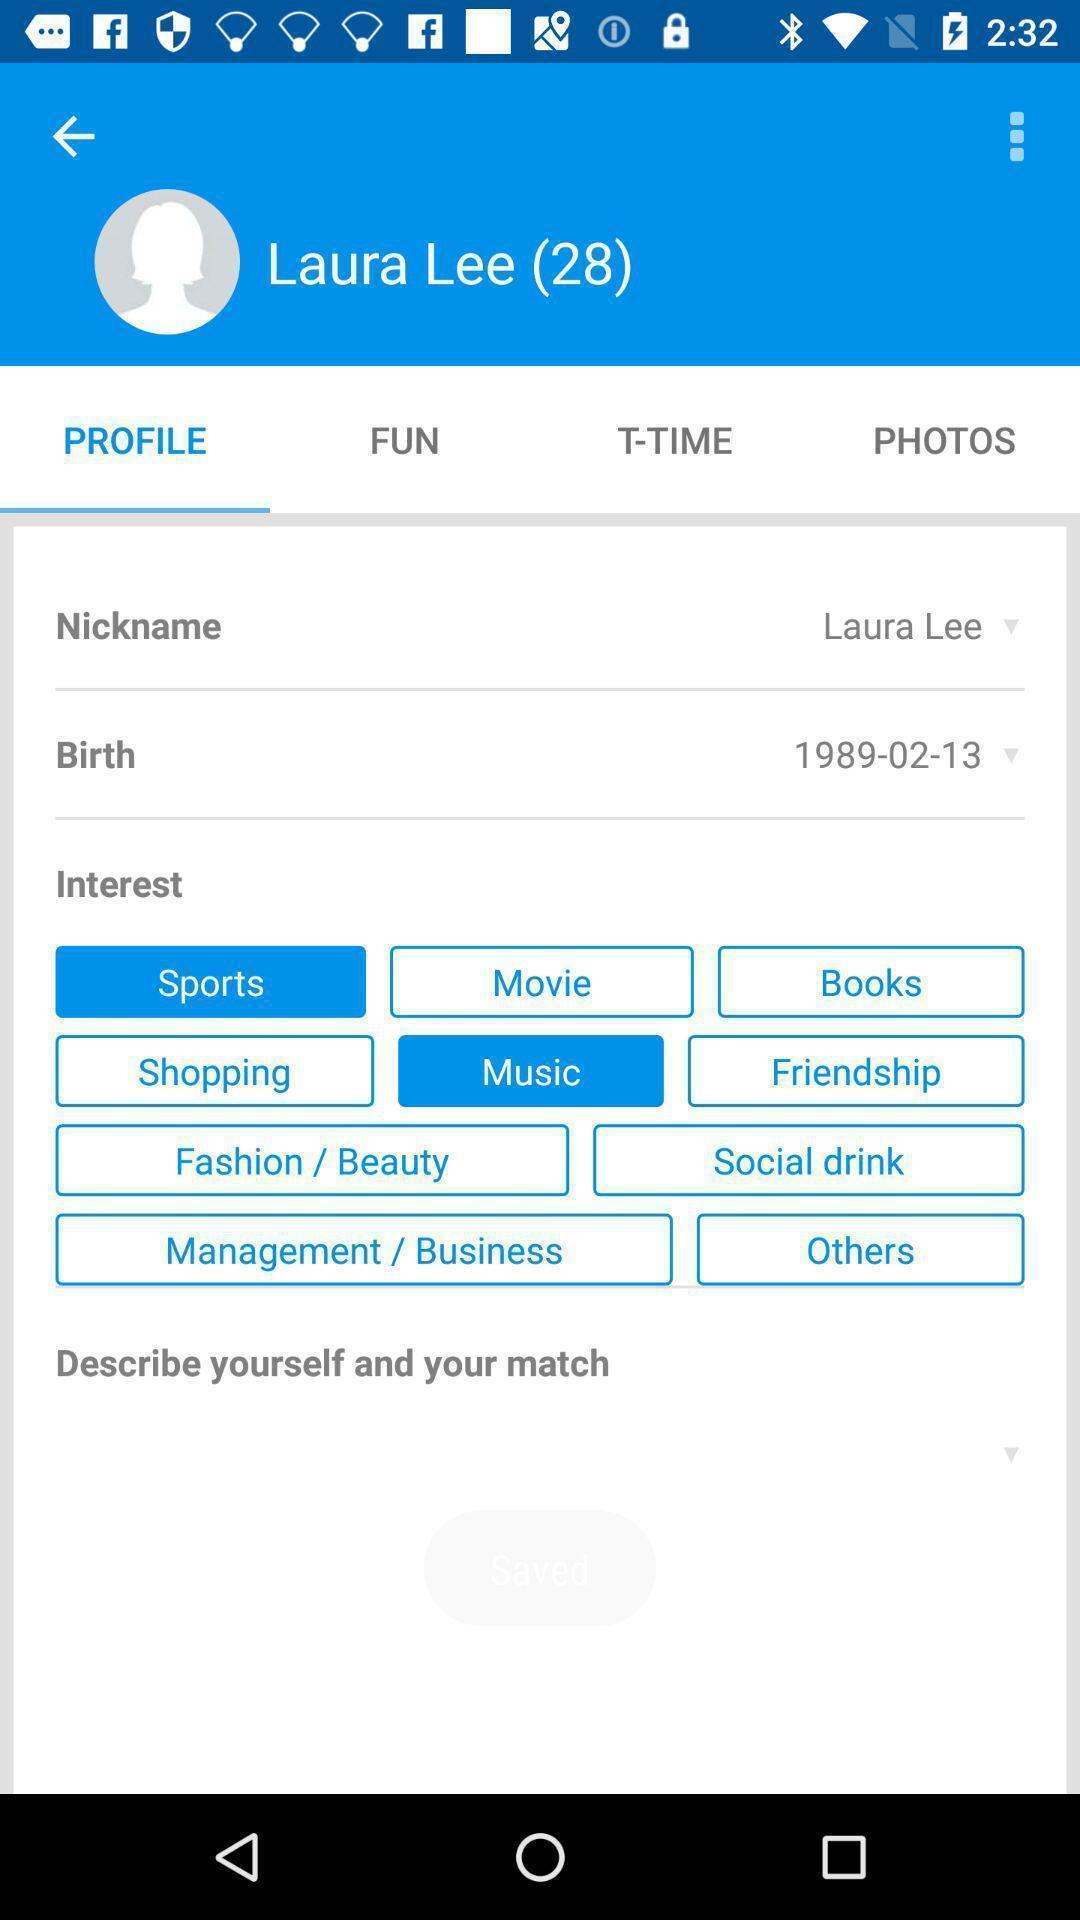Tell me about the visual elements in this screen capture. Screen shows details of a profile. 